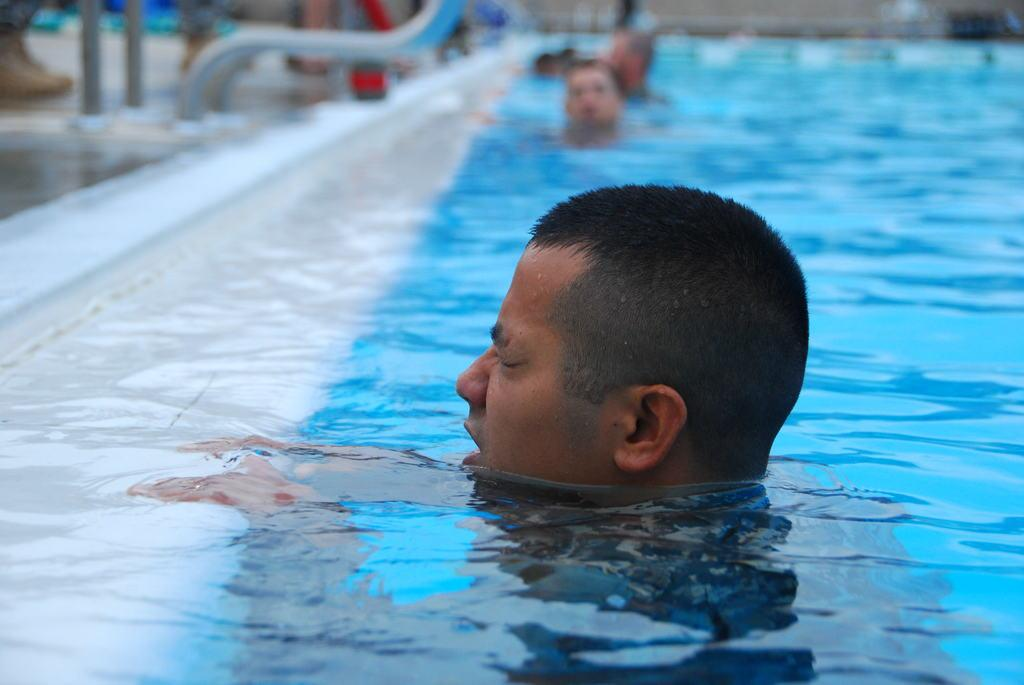What is the main subject of the image? There is a person in the pool. Can you describe the background of the image? The background of the image is slightly blurred. Are there any other people visible in the image? Yes, there are people in the background of the image. What type of bead is being used to decorate the pool in the image? There is no bead present in the image, and therefore no such decoration can be observed. What is the aftermath of the event in the image? There is no event depicted in the image, so it's not possible to determine the aftermath. 